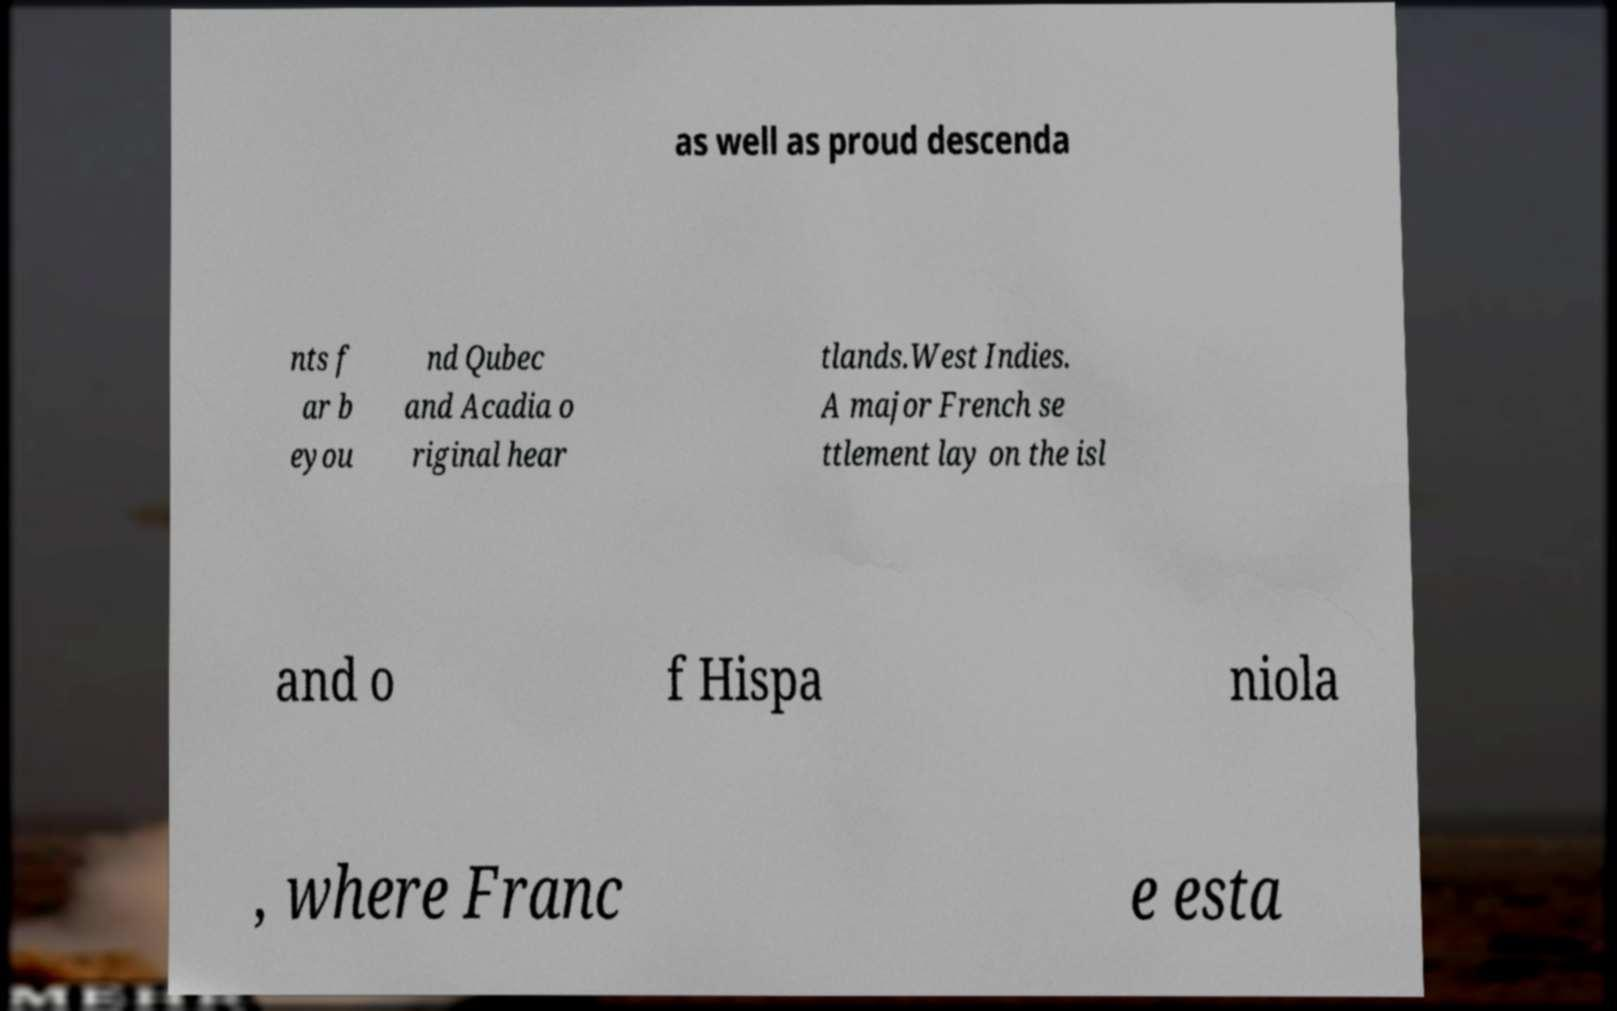I need the written content from this picture converted into text. Can you do that? as well as proud descenda nts f ar b eyou nd Qubec and Acadia o riginal hear tlands.West Indies. A major French se ttlement lay on the isl and o f Hispa niola , where Franc e esta 